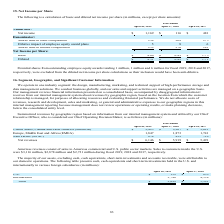From Netapp's financial document, Which years does the table provide information for cash, cash equivalents and short-term investments held? The document shows two values: 2019 and 2018. From the document: "April 26, 2019 April 27, 2018 April 28, 2017 April 26, 2019 April 27, 2018 April 28, 2017..." Also, What were the assets from U.S. in 2019? According to the financial document, 159 (in millions). The relevant text states: "U.S. $ 159 $ 853..." Also, What were the total assets in 2018? According to the financial document, 5,391 (in millions). The relevant text states: "Total $ 3,899 $ 5,391..." Also, can you calculate: What was the change in international assets between 2018 and 2019? Based on the calculation: 3,740-4,538, the result is -798 (in millions). This is based on the information: "International 3,740 4,538 International 3,740 4,538..." The key data points involved are: 3,740, 4,538. Also, can you calculate: What was the change in U.S. assets between 2018 and 2019? Based on the calculation: 159-853, the result is -694 (in millions). This is based on the information: "U.S. $ 159 $ 853 U.S. $ 159 $ 853..." The key data points involved are: 159, 853. Also, can you calculate: What was the percentage change in the total assets between 2018 and 2019? To answer this question, I need to perform calculations using the financial data. The calculation is: (3,899-5,391)/5,391, which equals -27.68 (percentage). This is based on the information: "Total $ 3,899 $ 5,391 Total $ 3,899 $ 5,391..." The key data points involved are: 3,899, 5,391. 